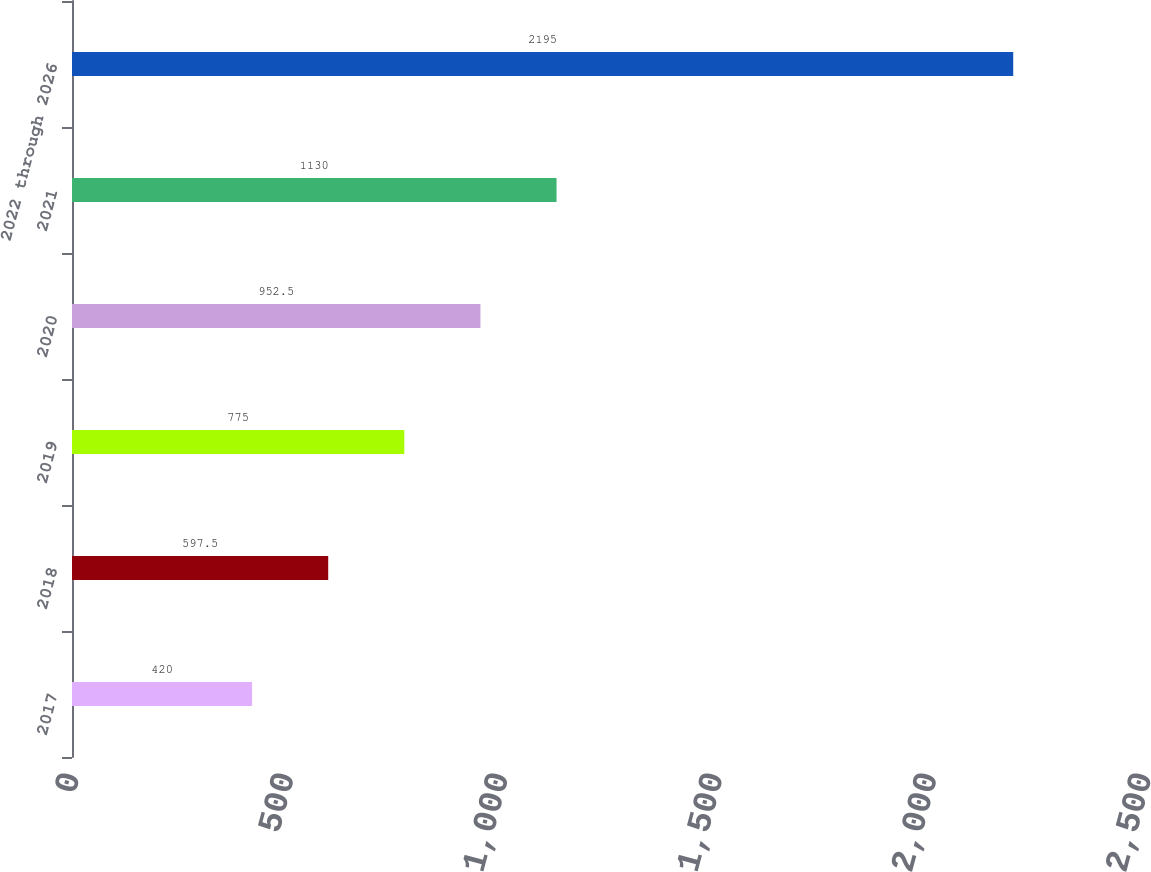<chart> <loc_0><loc_0><loc_500><loc_500><bar_chart><fcel>2017<fcel>2018<fcel>2019<fcel>2020<fcel>2021<fcel>2022 through 2026<nl><fcel>420<fcel>597.5<fcel>775<fcel>952.5<fcel>1130<fcel>2195<nl></chart> 